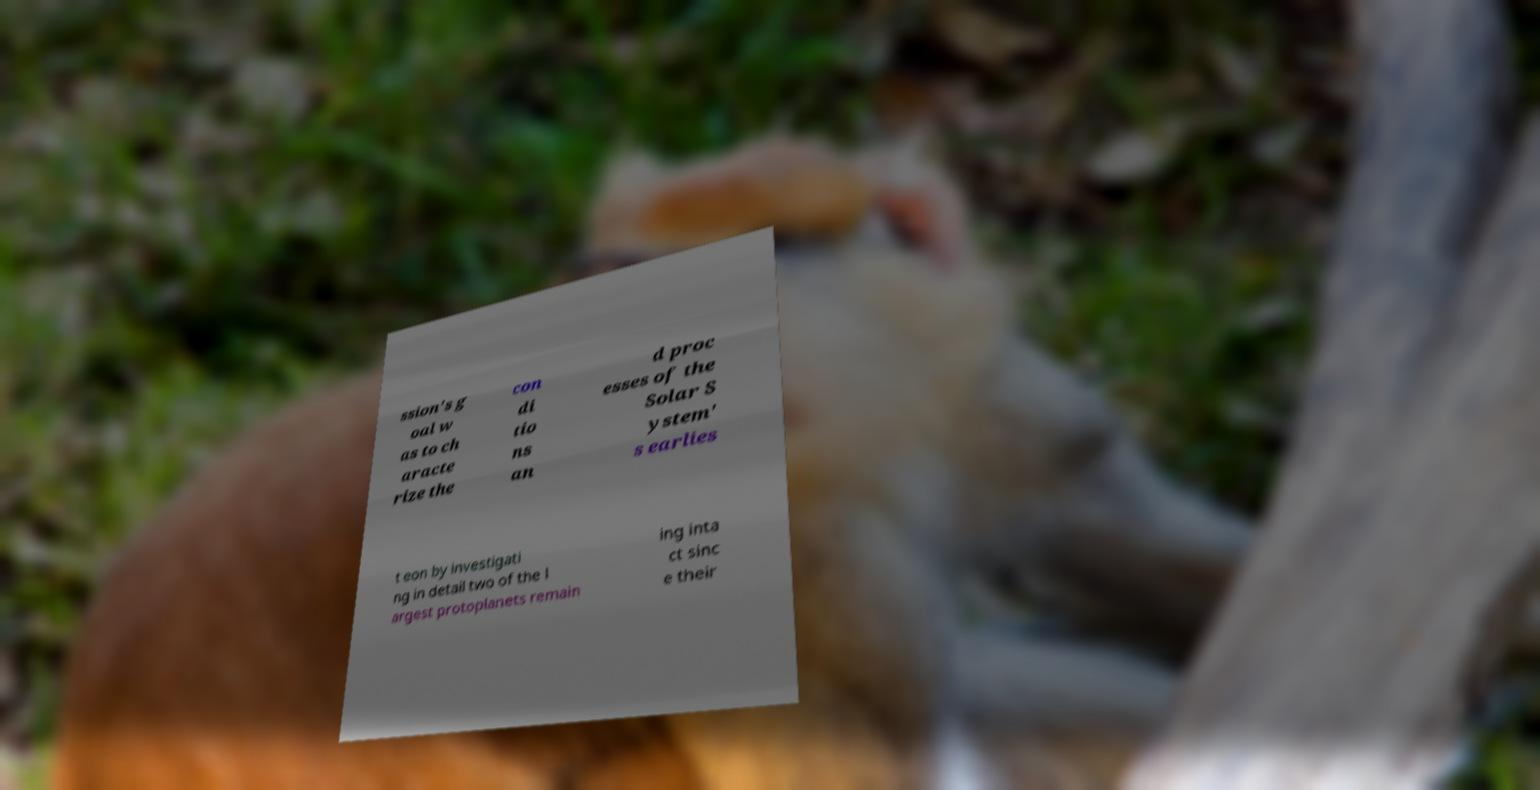Can you read and provide the text displayed in the image?This photo seems to have some interesting text. Can you extract and type it out for me? ssion's g oal w as to ch aracte rize the con di tio ns an d proc esses of the Solar S ystem' s earlies t eon by investigati ng in detail two of the l argest protoplanets remain ing inta ct sinc e their 